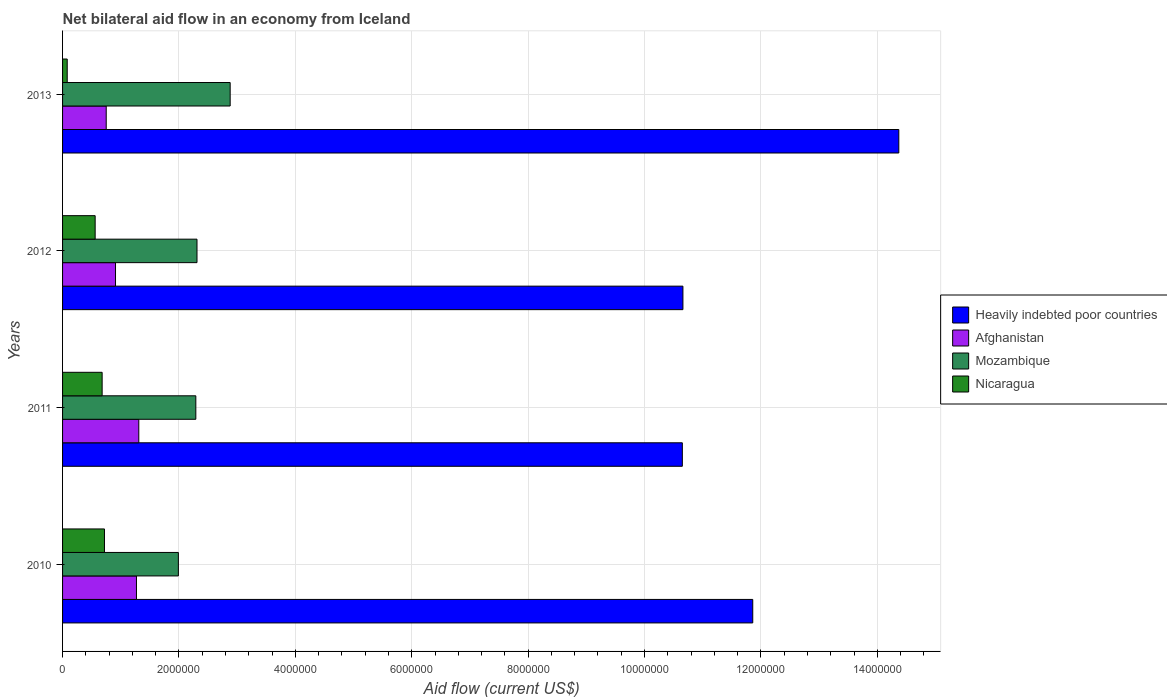Are the number of bars per tick equal to the number of legend labels?
Provide a short and direct response. Yes. Are the number of bars on each tick of the Y-axis equal?
Offer a terse response. Yes. How many bars are there on the 4th tick from the top?
Give a very brief answer. 4. In how many cases, is the number of bars for a given year not equal to the number of legend labels?
Make the answer very short. 0. What is the net bilateral aid flow in Nicaragua in 2013?
Provide a succinct answer. 8.00e+04. Across all years, what is the maximum net bilateral aid flow in Nicaragua?
Ensure brevity in your answer.  7.20e+05. Across all years, what is the minimum net bilateral aid flow in Afghanistan?
Make the answer very short. 7.50e+05. In which year was the net bilateral aid flow in Afghanistan minimum?
Provide a short and direct response. 2013. What is the total net bilateral aid flow in Afghanistan in the graph?
Make the answer very short. 4.24e+06. What is the difference between the net bilateral aid flow in Nicaragua in 2013 and the net bilateral aid flow in Afghanistan in 2012?
Your response must be concise. -8.30e+05. What is the average net bilateral aid flow in Nicaragua per year?
Give a very brief answer. 5.10e+05. In the year 2013, what is the difference between the net bilateral aid flow in Heavily indebted poor countries and net bilateral aid flow in Nicaragua?
Give a very brief answer. 1.43e+07. What is the ratio of the net bilateral aid flow in Mozambique in 2010 to that in 2012?
Ensure brevity in your answer.  0.86. What is the difference between the highest and the second highest net bilateral aid flow in Nicaragua?
Give a very brief answer. 4.00e+04. What is the difference between the highest and the lowest net bilateral aid flow in Nicaragua?
Offer a very short reply. 6.40e+05. What does the 4th bar from the top in 2011 represents?
Offer a terse response. Heavily indebted poor countries. What does the 3rd bar from the bottom in 2011 represents?
Your answer should be very brief. Mozambique. How many bars are there?
Offer a terse response. 16. Are all the bars in the graph horizontal?
Offer a terse response. Yes. How many years are there in the graph?
Give a very brief answer. 4. What is the difference between two consecutive major ticks on the X-axis?
Provide a succinct answer. 2.00e+06. Are the values on the major ticks of X-axis written in scientific E-notation?
Your response must be concise. No. Does the graph contain any zero values?
Ensure brevity in your answer.  No. Where does the legend appear in the graph?
Your answer should be compact. Center right. How many legend labels are there?
Provide a succinct answer. 4. What is the title of the graph?
Provide a succinct answer. Net bilateral aid flow in an economy from Iceland. Does "Colombia" appear as one of the legend labels in the graph?
Provide a succinct answer. No. What is the label or title of the Y-axis?
Your response must be concise. Years. What is the Aid flow (current US$) of Heavily indebted poor countries in 2010?
Provide a short and direct response. 1.19e+07. What is the Aid flow (current US$) in Afghanistan in 2010?
Give a very brief answer. 1.27e+06. What is the Aid flow (current US$) in Mozambique in 2010?
Make the answer very short. 1.99e+06. What is the Aid flow (current US$) of Nicaragua in 2010?
Provide a succinct answer. 7.20e+05. What is the Aid flow (current US$) of Heavily indebted poor countries in 2011?
Give a very brief answer. 1.06e+07. What is the Aid flow (current US$) of Afghanistan in 2011?
Provide a succinct answer. 1.31e+06. What is the Aid flow (current US$) in Mozambique in 2011?
Give a very brief answer. 2.29e+06. What is the Aid flow (current US$) of Nicaragua in 2011?
Your response must be concise. 6.80e+05. What is the Aid flow (current US$) in Heavily indebted poor countries in 2012?
Your response must be concise. 1.07e+07. What is the Aid flow (current US$) in Afghanistan in 2012?
Your answer should be very brief. 9.10e+05. What is the Aid flow (current US$) in Mozambique in 2012?
Provide a succinct answer. 2.31e+06. What is the Aid flow (current US$) in Nicaragua in 2012?
Your answer should be very brief. 5.60e+05. What is the Aid flow (current US$) in Heavily indebted poor countries in 2013?
Offer a very short reply. 1.44e+07. What is the Aid flow (current US$) of Afghanistan in 2013?
Offer a very short reply. 7.50e+05. What is the Aid flow (current US$) of Mozambique in 2013?
Provide a succinct answer. 2.88e+06. What is the Aid flow (current US$) in Nicaragua in 2013?
Provide a succinct answer. 8.00e+04. Across all years, what is the maximum Aid flow (current US$) of Heavily indebted poor countries?
Offer a terse response. 1.44e+07. Across all years, what is the maximum Aid flow (current US$) of Afghanistan?
Make the answer very short. 1.31e+06. Across all years, what is the maximum Aid flow (current US$) of Mozambique?
Your answer should be compact. 2.88e+06. Across all years, what is the maximum Aid flow (current US$) in Nicaragua?
Your response must be concise. 7.20e+05. Across all years, what is the minimum Aid flow (current US$) in Heavily indebted poor countries?
Your answer should be very brief. 1.06e+07. Across all years, what is the minimum Aid flow (current US$) in Afghanistan?
Provide a succinct answer. 7.50e+05. Across all years, what is the minimum Aid flow (current US$) in Mozambique?
Give a very brief answer. 1.99e+06. What is the total Aid flow (current US$) in Heavily indebted poor countries in the graph?
Your response must be concise. 4.75e+07. What is the total Aid flow (current US$) in Afghanistan in the graph?
Make the answer very short. 4.24e+06. What is the total Aid flow (current US$) in Mozambique in the graph?
Keep it short and to the point. 9.47e+06. What is the total Aid flow (current US$) in Nicaragua in the graph?
Give a very brief answer. 2.04e+06. What is the difference between the Aid flow (current US$) in Heavily indebted poor countries in 2010 and that in 2011?
Offer a terse response. 1.21e+06. What is the difference between the Aid flow (current US$) in Afghanistan in 2010 and that in 2011?
Your answer should be compact. -4.00e+04. What is the difference between the Aid flow (current US$) of Mozambique in 2010 and that in 2011?
Provide a succinct answer. -3.00e+05. What is the difference between the Aid flow (current US$) in Heavily indebted poor countries in 2010 and that in 2012?
Provide a succinct answer. 1.20e+06. What is the difference between the Aid flow (current US$) in Afghanistan in 2010 and that in 2012?
Give a very brief answer. 3.60e+05. What is the difference between the Aid flow (current US$) in Mozambique in 2010 and that in 2012?
Keep it short and to the point. -3.20e+05. What is the difference between the Aid flow (current US$) of Nicaragua in 2010 and that in 2012?
Offer a terse response. 1.60e+05. What is the difference between the Aid flow (current US$) of Heavily indebted poor countries in 2010 and that in 2013?
Offer a terse response. -2.51e+06. What is the difference between the Aid flow (current US$) of Afghanistan in 2010 and that in 2013?
Your answer should be very brief. 5.20e+05. What is the difference between the Aid flow (current US$) in Mozambique in 2010 and that in 2013?
Give a very brief answer. -8.90e+05. What is the difference between the Aid flow (current US$) of Nicaragua in 2010 and that in 2013?
Offer a terse response. 6.40e+05. What is the difference between the Aid flow (current US$) of Heavily indebted poor countries in 2011 and that in 2012?
Your answer should be very brief. -10000. What is the difference between the Aid flow (current US$) of Mozambique in 2011 and that in 2012?
Your response must be concise. -2.00e+04. What is the difference between the Aid flow (current US$) of Nicaragua in 2011 and that in 2012?
Your answer should be compact. 1.20e+05. What is the difference between the Aid flow (current US$) of Heavily indebted poor countries in 2011 and that in 2013?
Ensure brevity in your answer.  -3.72e+06. What is the difference between the Aid flow (current US$) in Afghanistan in 2011 and that in 2013?
Provide a short and direct response. 5.60e+05. What is the difference between the Aid flow (current US$) of Mozambique in 2011 and that in 2013?
Offer a very short reply. -5.90e+05. What is the difference between the Aid flow (current US$) in Nicaragua in 2011 and that in 2013?
Your response must be concise. 6.00e+05. What is the difference between the Aid flow (current US$) of Heavily indebted poor countries in 2012 and that in 2013?
Your answer should be very brief. -3.71e+06. What is the difference between the Aid flow (current US$) in Mozambique in 2012 and that in 2013?
Provide a short and direct response. -5.70e+05. What is the difference between the Aid flow (current US$) of Heavily indebted poor countries in 2010 and the Aid flow (current US$) of Afghanistan in 2011?
Your answer should be compact. 1.06e+07. What is the difference between the Aid flow (current US$) in Heavily indebted poor countries in 2010 and the Aid flow (current US$) in Mozambique in 2011?
Your response must be concise. 9.57e+06. What is the difference between the Aid flow (current US$) in Heavily indebted poor countries in 2010 and the Aid flow (current US$) in Nicaragua in 2011?
Offer a terse response. 1.12e+07. What is the difference between the Aid flow (current US$) of Afghanistan in 2010 and the Aid flow (current US$) of Mozambique in 2011?
Provide a succinct answer. -1.02e+06. What is the difference between the Aid flow (current US$) of Afghanistan in 2010 and the Aid flow (current US$) of Nicaragua in 2011?
Give a very brief answer. 5.90e+05. What is the difference between the Aid flow (current US$) in Mozambique in 2010 and the Aid flow (current US$) in Nicaragua in 2011?
Offer a terse response. 1.31e+06. What is the difference between the Aid flow (current US$) of Heavily indebted poor countries in 2010 and the Aid flow (current US$) of Afghanistan in 2012?
Provide a short and direct response. 1.10e+07. What is the difference between the Aid flow (current US$) in Heavily indebted poor countries in 2010 and the Aid flow (current US$) in Mozambique in 2012?
Your answer should be compact. 9.55e+06. What is the difference between the Aid flow (current US$) in Heavily indebted poor countries in 2010 and the Aid flow (current US$) in Nicaragua in 2012?
Make the answer very short. 1.13e+07. What is the difference between the Aid flow (current US$) of Afghanistan in 2010 and the Aid flow (current US$) of Mozambique in 2012?
Your answer should be very brief. -1.04e+06. What is the difference between the Aid flow (current US$) of Afghanistan in 2010 and the Aid flow (current US$) of Nicaragua in 2012?
Keep it short and to the point. 7.10e+05. What is the difference between the Aid flow (current US$) of Mozambique in 2010 and the Aid flow (current US$) of Nicaragua in 2012?
Offer a very short reply. 1.43e+06. What is the difference between the Aid flow (current US$) in Heavily indebted poor countries in 2010 and the Aid flow (current US$) in Afghanistan in 2013?
Ensure brevity in your answer.  1.11e+07. What is the difference between the Aid flow (current US$) of Heavily indebted poor countries in 2010 and the Aid flow (current US$) of Mozambique in 2013?
Offer a terse response. 8.98e+06. What is the difference between the Aid flow (current US$) of Heavily indebted poor countries in 2010 and the Aid flow (current US$) of Nicaragua in 2013?
Make the answer very short. 1.18e+07. What is the difference between the Aid flow (current US$) in Afghanistan in 2010 and the Aid flow (current US$) in Mozambique in 2013?
Your response must be concise. -1.61e+06. What is the difference between the Aid flow (current US$) of Afghanistan in 2010 and the Aid flow (current US$) of Nicaragua in 2013?
Your response must be concise. 1.19e+06. What is the difference between the Aid flow (current US$) of Mozambique in 2010 and the Aid flow (current US$) of Nicaragua in 2013?
Provide a succinct answer. 1.91e+06. What is the difference between the Aid flow (current US$) of Heavily indebted poor countries in 2011 and the Aid flow (current US$) of Afghanistan in 2012?
Offer a terse response. 9.74e+06. What is the difference between the Aid flow (current US$) of Heavily indebted poor countries in 2011 and the Aid flow (current US$) of Mozambique in 2012?
Make the answer very short. 8.34e+06. What is the difference between the Aid flow (current US$) of Heavily indebted poor countries in 2011 and the Aid flow (current US$) of Nicaragua in 2012?
Your answer should be very brief. 1.01e+07. What is the difference between the Aid flow (current US$) of Afghanistan in 2011 and the Aid flow (current US$) of Nicaragua in 2012?
Make the answer very short. 7.50e+05. What is the difference between the Aid flow (current US$) of Mozambique in 2011 and the Aid flow (current US$) of Nicaragua in 2012?
Your response must be concise. 1.73e+06. What is the difference between the Aid flow (current US$) of Heavily indebted poor countries in 2011 and the Aid flow (current US$) of Afghanistan in 2013?
Ensure brevity in your answer.  9.90e+06. What is the difference between the Aid flow (current US$) in Heavily indebted poor countries in 2011 and the Aid flow (current US$) in Mozambique in 2013?
Offer a terse response. 7.77e+06. What is the difference between the Aid flow (current US$) in Heavily indebted poor countries in 2011 and the Aid flow (current US$) in Nicaragua in 2013?
Your answer should be very brief. 1.06e+07. What is the difference between the Aid flow (current US$) in Afghanistan in 2011 and the Aid flow (current US$) in Mozambique in 2013?
Your response must be concise. -1.57e+06. What is the difference between the Aid flow (current US$) of Afghanistan in 2011 and the Aid flow (current US$) of Nicaragua in 2013?
Your answer should be compact. 1.23e+06. What is the difference between the Aid flow (current US$) in Mozambique in 2011 and the Aid flow (current US$) in Nicaragua in 2013?
Your response must be concise. 2.21e+06. What is the difference between the Aid flow (current US$) in Heavily indebted poor countries in 2012 and the Aid flow (current US$) in Afghanistan in 2013?
Your answer should be compact. 9.91e+06. What is the difference between the Aid flow (current US$) of Heavily indebted poor countries in 2012 and the Aid flow (current US$) of Mozambique in 2013?
Provide a short and direct response. 7.78e+06. What is the difference between the Aid flow (current US$) of Heavily indebted poor countries in 2012 and the Aid flow (current US$) of Nicaragua in 2013?
Your answer should be very brief. 1.06e+07. What is the difference between the Aid flow (current US$) of Afghanistan in 2012 and the Aid flow (current US$) of Mozambique in 2013?
Provide a short and direct response. -1.97e+06. What is the difference between the Aid flow (current US$) in Afghanistan in 2012 and the Aid flow (current US$) in Nicaragua in 2013?
Offer a terse response. 8.30e+05. What is the difference between the Aid flow (current US$) of Mozambique in 2012 and the Aid flow (current US$) of Nicaragua in 2013?
Keep it short and to the point. 2.23e+06. What is the average Aid flow (current US$) in Heavily indebted poor countries per year?
Make the answer very short. 1.19e+07. What is the average Aid flow (current US$) of Afghanistan per year?
Offer a terse response. 1.06e+06. What is the average Aid flow (current US$) in Mozambique per year?
Your answer should be very brief. 2.37e+06. What is the average Aid flow (current US$) of Nicaragua per year?
Provide a succinct answer. 5.10e+05. In the year 2010, what is the difference between the Aid flow (current US$) of Heavily indebted poor countries and Aid flow (current US$) of Afghanistan?
Your response must be concise. 1.06e+07. In the year 2010, what is the difference between the Aid flow (current US$) in Heavily indebted poor countries and Aid flow (current US$) in Mozambique?
Your answer should be very brief. 9.87e+06. In the year 2010, what is the difference between the Aid flow (current US$) of Heavily indebted poor countries and Aid flow (current US$) of Nicaragua?
Keep it short and to the point. 1.11e+07. In the year 2010, what is the difference between the Aid flow (current US$) in Afghanistan and Aid flow (current US$) in Mozambique?
Ensure brevity in your answer.  -7.20e+05. In the year 2010, what is the difference between the Aid flow (current US$) of Mozambique and Aid flow (current US$) of Nicaragua?
Your response must be concise. 1.27e+06. In the year 2011, what is the difference between the Aid flow (current US$) in Heavily indebted poor countries and Aid flow (current US$) in Afghanistan?
Provide a short and direct response. 9.34e+06. In the year 2011, what is the difference between the Aid flow (current US$) in Heavily indebted poor countries and Aid flow (current US$) in Mozambique?
Offer a terse response. 8.36e+06. In the year 2011, what is the difference between the Aid flow (current US$) in Heavily indebted poor countries and Aid flow (current US$) in Nicaragua?
Offer a very short reply. 9.97e+06. In the year 2011, what is the difference between the Aid flow (current US$) in Afghanistan and Aid flow (current US$) in Mozambique?
Offer a terse response. -9.80e+05. In the year 2011, what is the difference between the Aid flow (current US$) of Afghanistan and Aid flow (current US$) of Nicaragua?
Your answer should be very brief. 6.30e+05. In the year 2011, what is the difference between the Aid flow (current US$) in Mozambique and Aid flow (current US$) in Nicaragua?
Keep it short and to the point. 1.61e+06. In the year 2012, what is the difference between the Aid flow (current US$) of Heavily indebted poor countries and Aid flow (current US$) of Afghanistan?
Your response must be concise. 9.75e+06. In the year 2012, what is the difference between the Aid flow (current US$) of Heavily indebted poor countries and Aid flow (current US$) of Mozambique?
Provide a short and direct response. 8.35e+06. In the year 2012, what is the difference between the Aid flow (current US$) of Heavily indebted poor countries and Aid flow (current US$) of Nicaragua?
Give a very brief answer. 1.01e+07. In the year 2012, what is the difference between the Aid flow (current US$) of Afghanistan and Aid flow (current US$) of Mozambique?
Give a very brief answer. -1.40e+06. In the year 2012, what is the difference between the Aid flow (current US$) in Mozambique and Aid flow (current US$) in Nicaragua?
Your answer should be compact. 1.75e+06. In the year 2013, what is the difference between the Aid flow (current US$) in Heavily indebted poor countries and Aid flow (current US$) in Afghanistan?
Make the answer very short. 1.36e+07. In the year 2013, what is the difference between the Aid flow (current US$) of Heavily indebted poor countries and Aid flow (current US$) of Mozambique?
Offer a terse response. 1.15e+07. In the year 2013, what is the difference between the Aid flow (current US$) of Heavily indebted poor countries and Aid flow (current US$) of Nicaragua?
Keep it short and to the point. 1.43e+07. In the year 2013, what is the difference between the Aid flow (current US$) of Afghanistan and Aid flow (current US$) of Mozambique?
Provide a short and direct response. -2.13e+06. In the year 2013, what is the difference between the Aid flow (current US$) in Afghanistan and Aid flow (current US$) in Nicaragua?
Make the answer very short. 6.70e+05. In the year 2013, what is the difference between the Aid flow (current US$) in Mozambique and Aid flow (current US$) in Nicaragua?
Provide a short and direct response. 2.80e+06. What is the ratio of the Aid flow (current US$) of Heavily indebted poor countries in 2010 to that in 2011?
Offer a very short reply. 1.11. What is the ratio of the Aid flow (current US$) in Afghanistan in 2010 to that in 2011?
Your answer should be very brief. 0.97. What is the ratio of the Aid flow (current US$) of Mozambique in 2010 to that in 2011?
Provide a succinct answer. 0.87. What is the ratio of the Aid flow (current US$) in Nicaragua in 2010 to that in 2011?
Keep it short and to the point. 1.06. What is the ratio of the Aid flow (current US$) in Heavily indebted poor countries in 2010 to that in 2012?
Provide a succinct answer. 1.11. What is the ratio of the Aid flow (current US$) in Afghanistan in 2010 to that in 2012?
Give a very brief answer. 1.4. What is the ratio of the Aid flow (current US$) in Mozambique in 2010 to that in 2012?
Provide a succinct answer. 0.86. What is the ratio of the Aid flow (current US$) of Nicaragua in 2010 to that in 2012?
Your response must be concise. 1.29. What is the ratio of the Aid flow (current US$) of Heavily indebted poor countries in 2010 to that in 2013?
Ensure brevity in your answer.  0.83. What is the ratio of the Aid flow (current US$) of Afghanistan in 2010 to that in 2013?
Provide a succinct answer. 1.69. What is the ratio of the Aid flow (current US$) of Mozambique in 2010 to that in 2013?
Keep it short and to the point. 0.69. What is the ratio of the Aid flow (current US$) in Nicaragua in 2010 to that in 2013?
Provide a succinct answer. 9. What is the ratio of the Aid flow (current US$) of Heavily indebted poor countries in 2011 to that in 2012?
Your answer should be very brief. 1. What is the ratio of the Aid flow (current US$) in Afghanistan in 2011 to that in 2012?
Offer a very short reply. 1.44. What is the ratio of the Aid flow (current US$) in Mozambique in 2011 to that in 2012?
Your answer should be very brief. 0.99. What is the ratio of the Aid flow (current US$) in Nicaragua in 2011 to that in 2012?
Your answer should be compact. 1.21. What is the ratio of the Aid flow (current US$) in Heavily indebted poor countries in 2011 to that in 2013?
Your answer should be very brief. 0.74. What is the ratio of the Aid flow (current US$) of Afghanistan in 2011 to that in 2013?
Keep it short and to the point. 1.75. What is the ratio of the Aid flow (current US$) in Mozambique in 2011 to that in 2013?
Your answer should be compact. 0.8. What is the ratio of the Aid flow (current US$) of Heavily indebted poor countries in 2012 to that in 2013?
Keep it short and to the point. 0.74. What is the ratio of the Aid flow (current US$) in Afghanistan in 2012 to that in 2013?
Give a very brief answer. 1.21. What is the ratio of the Aid flow (current US$) in Mozambique in 2012 to that in 2013?
Your response must be concise. 0.8. What is the difference between the highest and the second highest Aid flow (current US$) in Heavily indebted poor countries?
Your answer should be very brief. 2.51e+06. What is the difference between the highest and the second highest Aid flow (current US$) in Afghanistan?
Make the answer very short. 4.00e+04. What is the difference between the highest and the second highest Aid flow (current US$) in Mozambique?
Ensure brevity in your answer.  5.70e+05. What is the difference between the highest and the second highest Aid flow (current US$) in Nicaragua?
Provide a short and direct response. 4.00e+04. What is the difference between the highest and the lowest Aid flow (current US$) of Heavily indebted poor countries?
Ensure brevity in your answer.  3.72e+06. What is the difference between the highest and the lowest Aid flow (current US$) in Afghanistan?
Offer a very short reply. 5.60e+05. What is the difference between the highest and the lowest Aid flow (current US$) of Mozambique?
Your response must be concise. 8.90e+05. What is the difference between the highest and the lowest Aid flow (current US$) in Nicaragua?
Make the answer very short. 6.40e+05. 